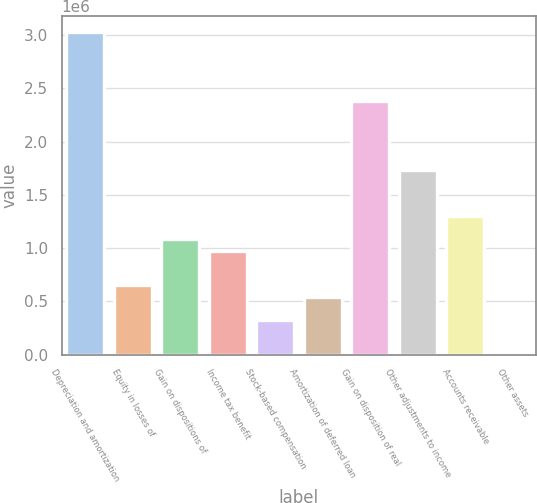Convert chart to OTSL. <chart><loc_0><loc_0><loc_500><loc_500><bar_chart><fcel>Depreciation and amortization<fcel>Equity in losses of<fcel>Gain on dispositions of<fcel>Income tax benefit<fcel>Stock-based compensation<fcel>Amortization of deferred loan<fcel>Gain on disposition of real<fcel>Other adjustments to income<fcel>Accounts receivable<fcel>Other assets<nl><fcel>3.02656e+06<fcel>650465<fcel>1.08248e+06<fcel>974478<fcel>326453<fcel>542461<fcel>2.37853e+06<fcel>1.73051e+06<fcel>1.29849e+06<fcel>2440<nl></chart> 